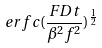<formula> <loc_0><loc_0><loc_500><loc_500>e r f c ( \frac { F D t } { \beta ^ { 2 } f ^ { 2 } } ) ^ { \frac { 1 } { 2 } }</formula> 